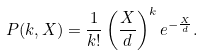<formula> <loc_0><loc_0><loc_500><loc_500>P ( k , X ) = \frac { 1 } { k ! } \left ( \frac { X } { d } \right ) ^ { k } e ^ { - \frac { X } { d } } .</formula> 